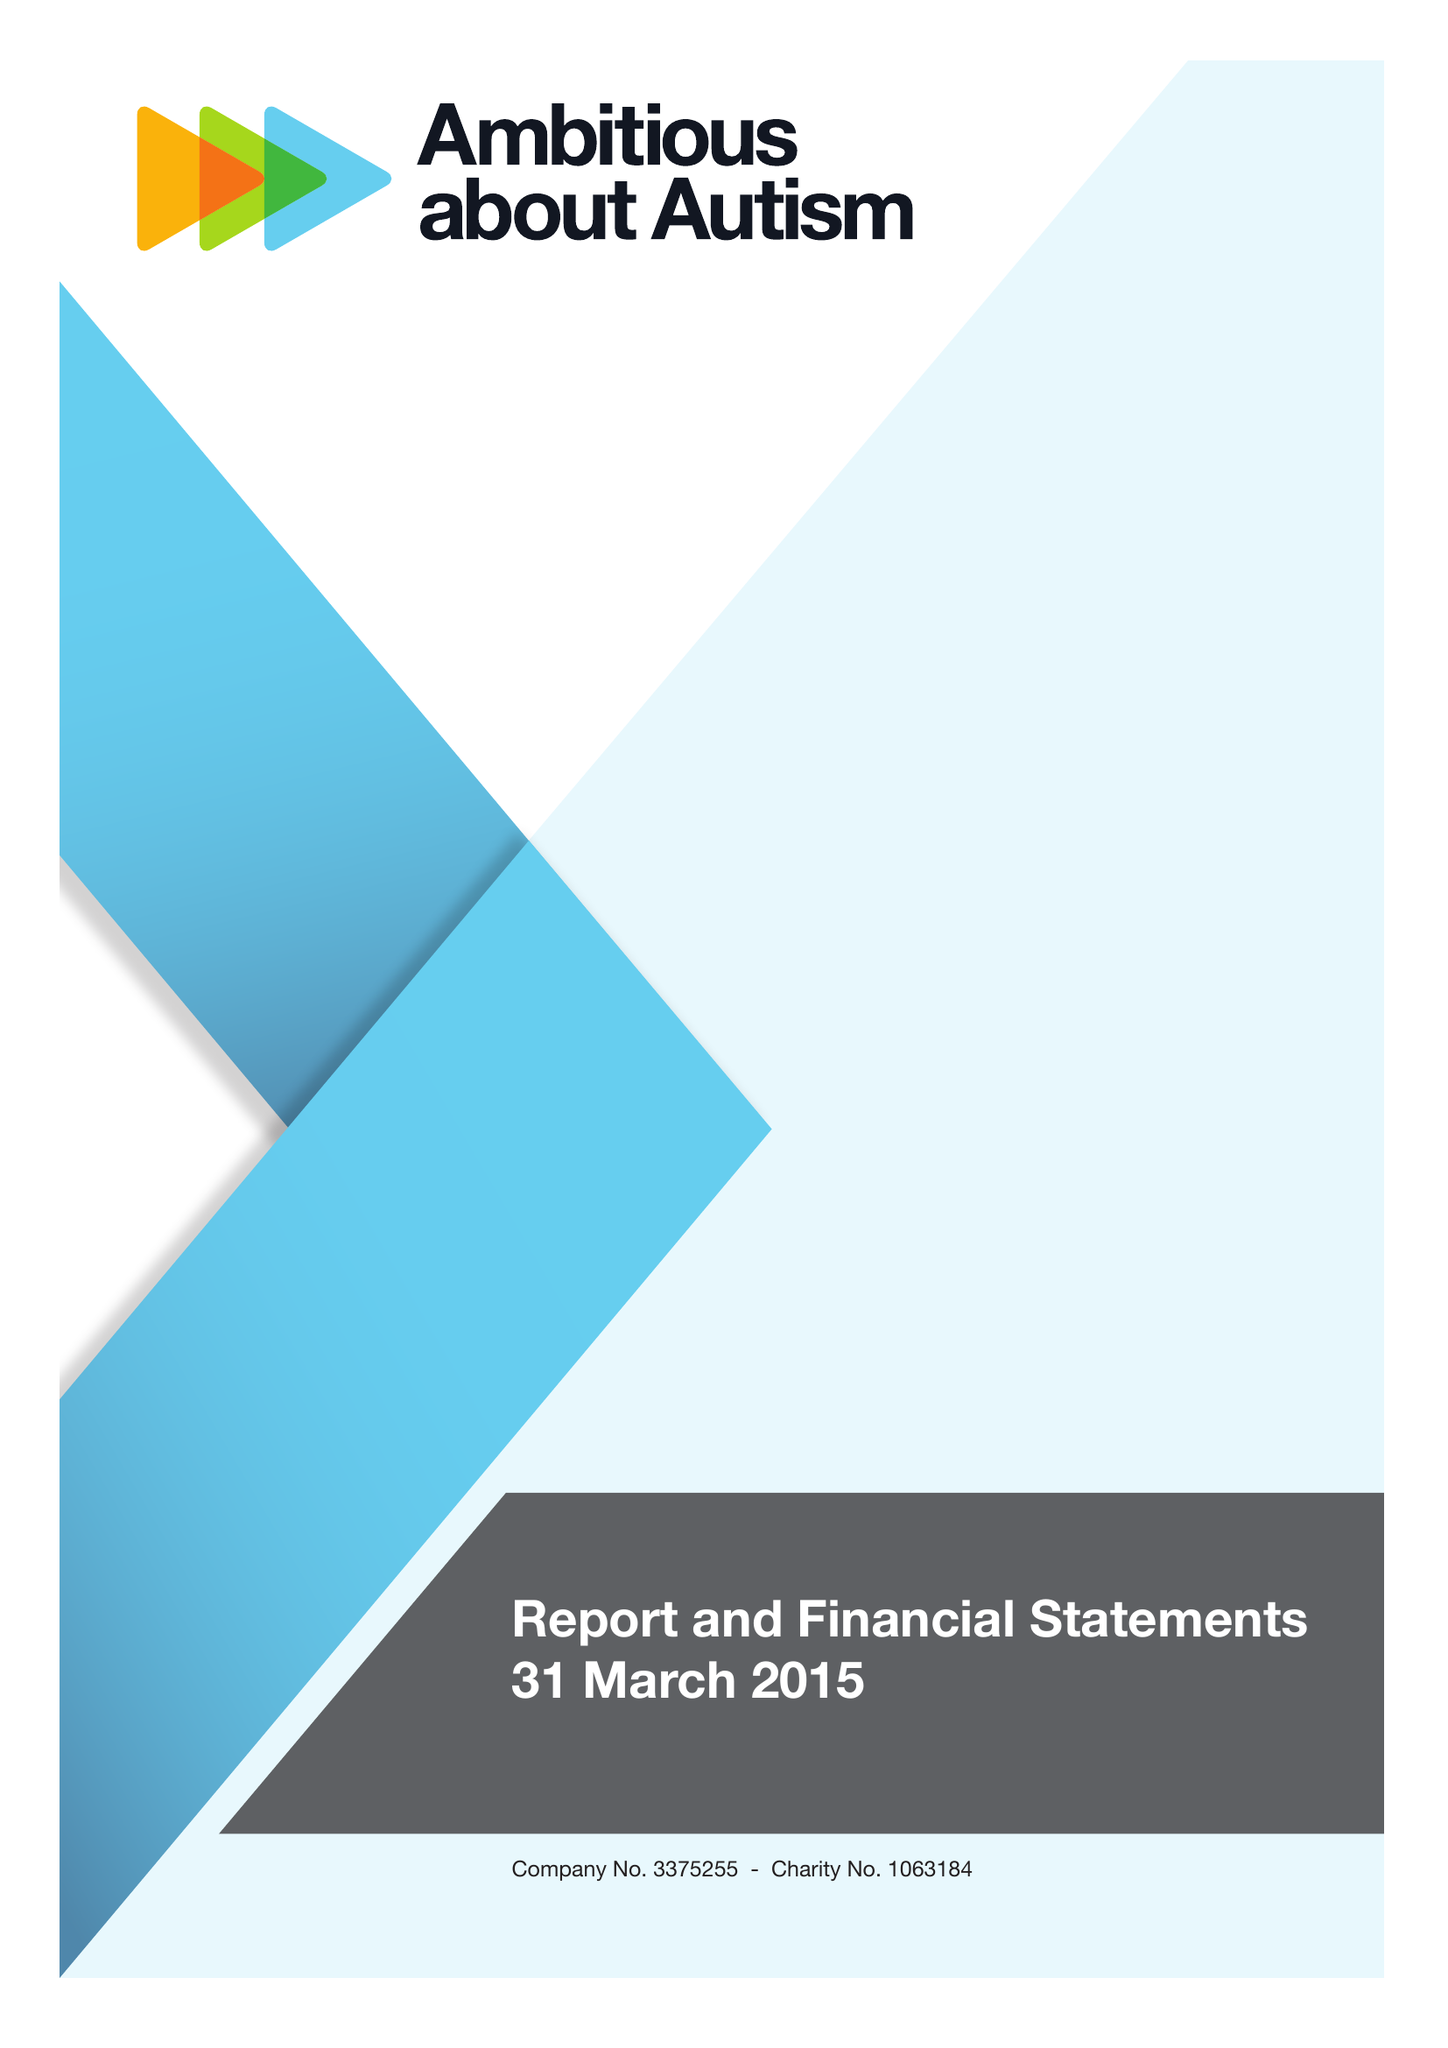What is the value for the report_date?
Answer the question using a single word or phrase. 2015-03-31 